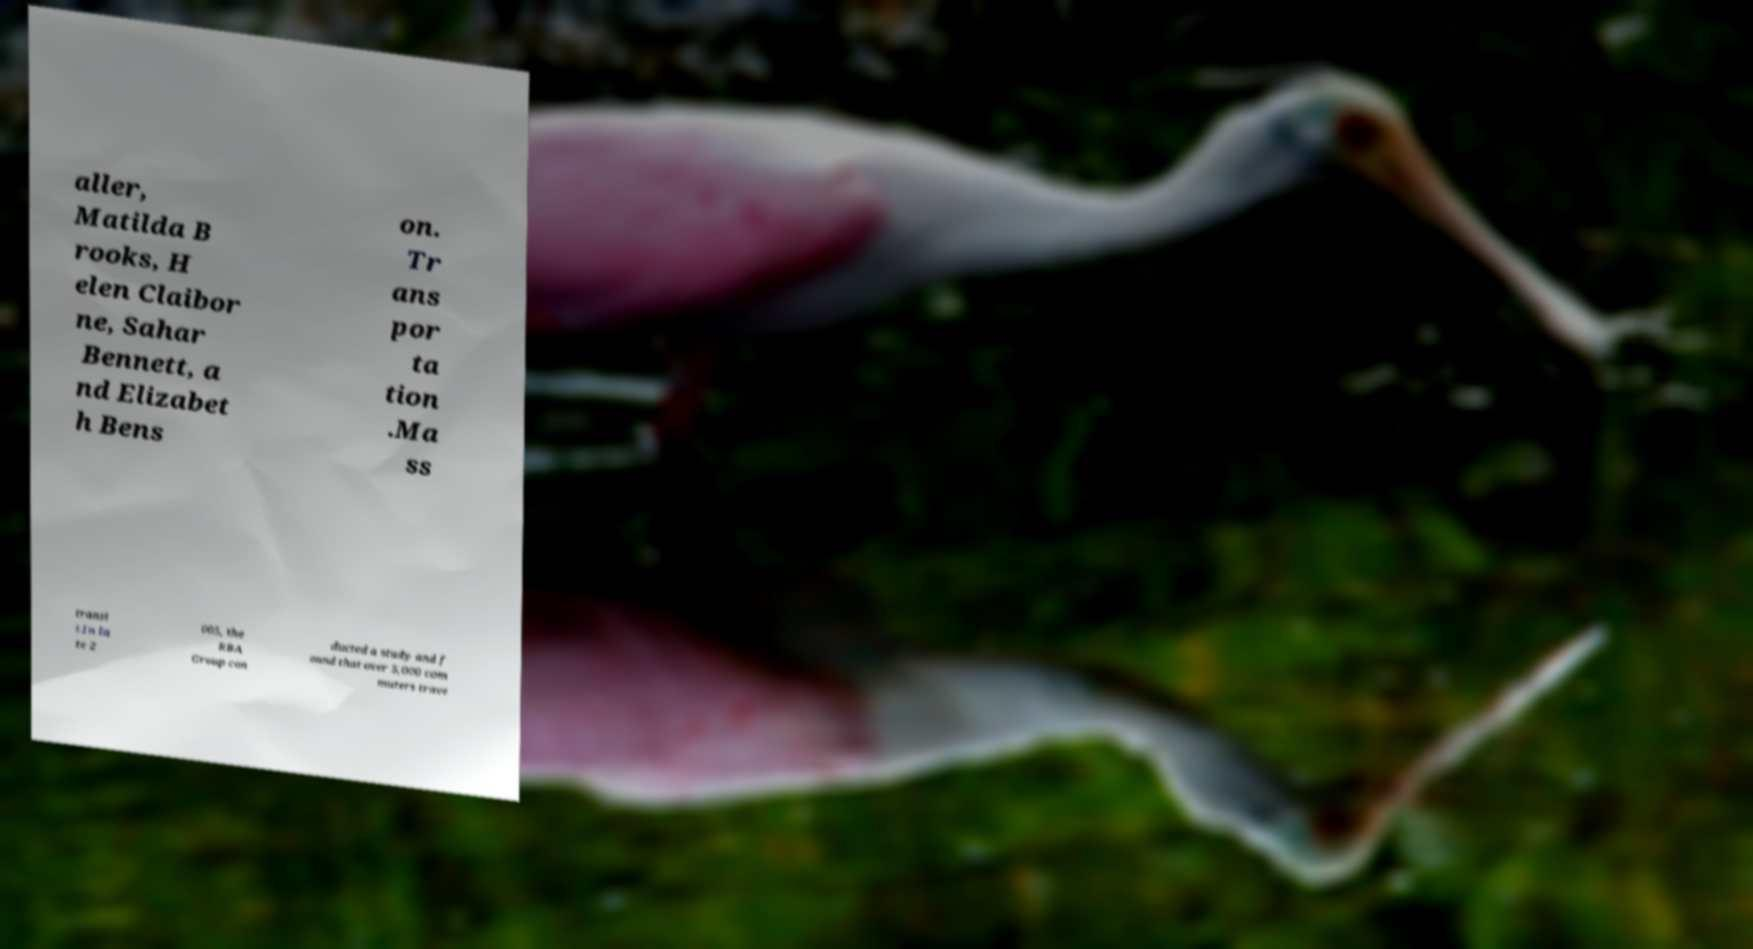Could you extract and type out the text from this image? aller, Matilda B rooks, H elen Claibor ne, Sahar Bennett, a nd Elizabet h Bens on. Tr ans por ta tion .Ma ss transi t.In la te 2 005, the RBA Group con ducted a study and f ound that over 5,000 com muters trave 